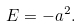<formula> <loc_0><loc_0><loc_500><loc_500>E = - a ^ { 2 } .</formula> 